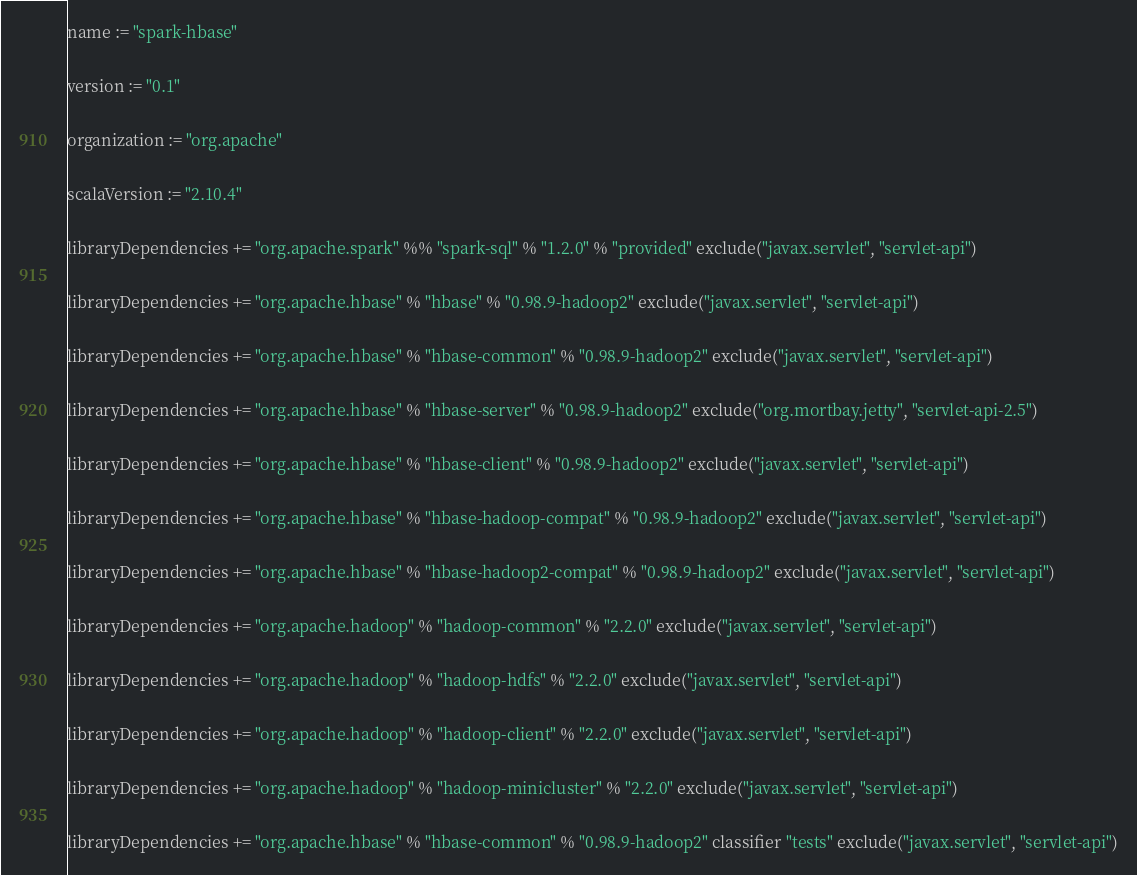<code> <loc_0><loc_0><loc_500><loc_500><_Scala_>name := "spark-hbase"

version := "0.1"

organization := "org.apache"

scalaVersion := "2.10.4"

libraryDependencies += "org.apache.spark" %% "spark-sql" % "1.2.0" % "provided" exclude("javax.servlet", "servlet-api")

libraryDependencies += "org.apache.hbase" % "hbase" % "0.98.9-hadoop2" exclude("javax.servlet", "servlet-api")

libraryDependencies += "org.apache.hbase" % "hbase-common" % "0.98.9-hadoop2" exclude("javax.servlet", "servlet-api")

libraryDependencies += "org.apache.hbase" % "hbase-server" % "0.98.9-hadoop2" exclude("org.mortbay.jetty", "servlet-api-2.5")

libraryDependencies += "org.apache.hbase" % "hbase-client" % "0.98.9-hadoop2" exclude("javax.servlet", "servlet-api")

libraryDependencies += "org.apache.hbase" % "hbase-hadoop-compat" % "0.98.9-hadoop2" exclude("javax.servlet", "servlet-api")

libraryDependencies += "org.apache.hbase" % "hbase-hadoop2-compat" % "0.98.9-hadoop2" exclude("javax.servlet", "servlet-api")

libraryDependencies += "org.apache.hadoop" % "hadoop-common" % "2.2.0" exclude("javax.servlet", "servlet-api")

libraryDependencies += "org.apache.hadoop" % "hadoop-hdfs" % "2.2.0" exclude("javax.servlet", "servlet-api")

libraryDependencies += "org.apache.hadoop" % "hadoop-client" % "2.2.0" exclude("javax.servlet", "servlet-api")

libraryDependencies += "org.apache.hadoop" % "hadoop-minicluster" % "2.2.0" exclude("javax.servlet", "servlet-api")

libraryDependencies += "org.apache.hbase" % "hbase-common" % "0.98.9-hadoop2" classifier "tests" exclude("javax.servlet", "servlet-api")
</code> 